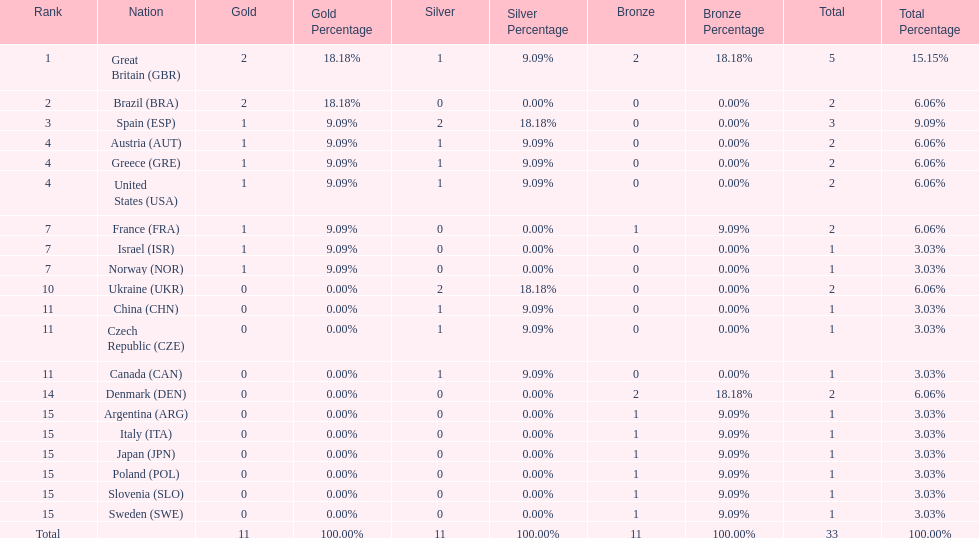Which nation was the only one to receive 3 medals? Spain (ESP). 